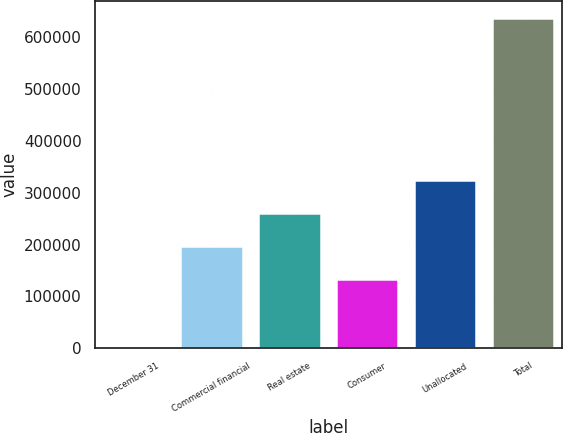<chart> <loc_0><loc_0><loc_500><loc_500><bar_chart><fcel>December 31<fcel>Commercial financial<fcel>Real estate<fcel>Consumer<fcel>Unallocated<fcel>Total<nl><fcel>2005<fcel>197107<fcel>260673<fcel>133541<fcel>324238<fcel>637663<nl></chart> 